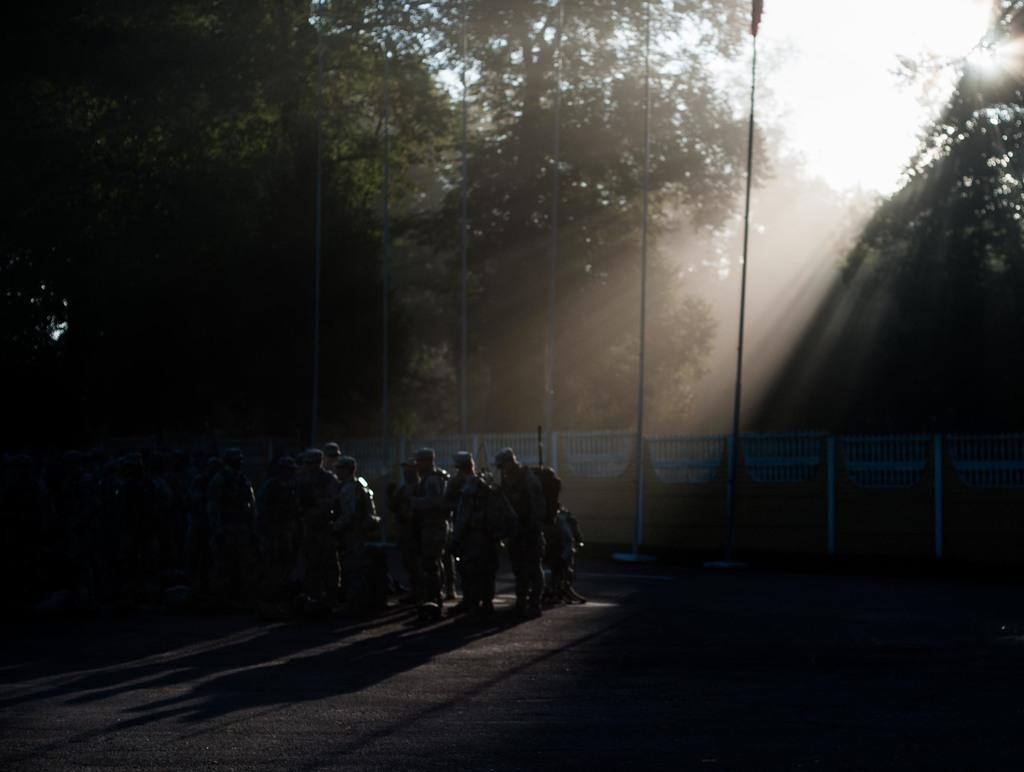What is happening in the image? There are people standing in the image. What can be seen in the background of the image? There are trees in the image. What type of barrier is present in the image? There is a metal fence in the image. How many cows are visible in the image? There are no cows present in the image. What type of cap is being worn by the people in the image? There is no information about caps or any headwear in the image. 